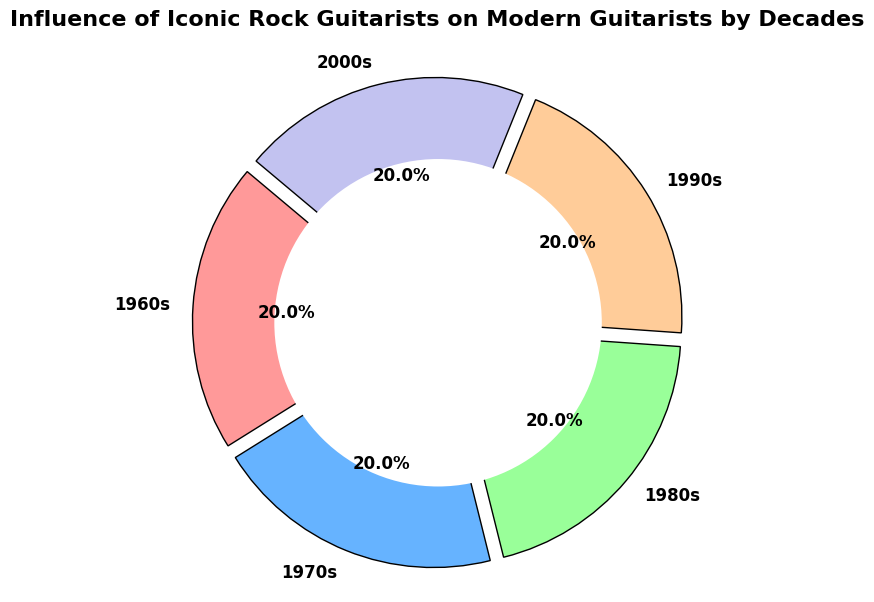Which decade had the highest influence on modern guitarists? In the pie chart, the 1970s section appears the largest, indicating it had the highest influence.
Answer: 1970s Which two decades combined make up half of the total influence? The pie chart shows 1970s at 30% and 1980s at 20%, combining to 50% of the total influence.
Answer: 1970s and 1980s Visually, which decade has the smallest influence, based on the size of its section? The segment for the 1960s is the smallest in the pie chart, indicating the lowest influence.
Answer: 1960s Compare the influence between the 1990s and 2000s. Which is higher and by how much? According to the pie chart, the 2000s influence is 25%, while the 1990s influence is 20%. The 2000s have a higher influence by 5%.
Answer: 2000s by 5% What is the total influence percentage of the 1960s and 1980s together? The pie chart segments for the 1960s and 1980s show 25% and 20%, respectively. Summing these gives 25% + 20% = 45%.
Answer: 45% Which decades have an influence percentage of 20% or more? By observing the pie chart, the decades with 20% or more are the 1960s (25%), 1970s (30%), 1980s (20%), 1990s (20%), and 2000s (25%).
Answer: 1960s, 1970s, 1980s, 1990s, 2000s If the 1960s and 1970s are combined, what is their total influence percentage compared to the combined influence of the 1980s, 1990s, and 2000s? From the pie chart: 1960s (25%) + 1970s (30%) = 55%; 1980s (20%) + 1990s (20%) + 2000s (25%) = 65%. The combined influence of the 1980s, 1990s, and 2000s is 10% more.
Answer: 55% and 65% Which decade's influence is exactly one-fourth of the total influence? The pie chart shows that the influence of the 1960s is 25%, which is one-fourth of the total influence.
Answer: 1960s 